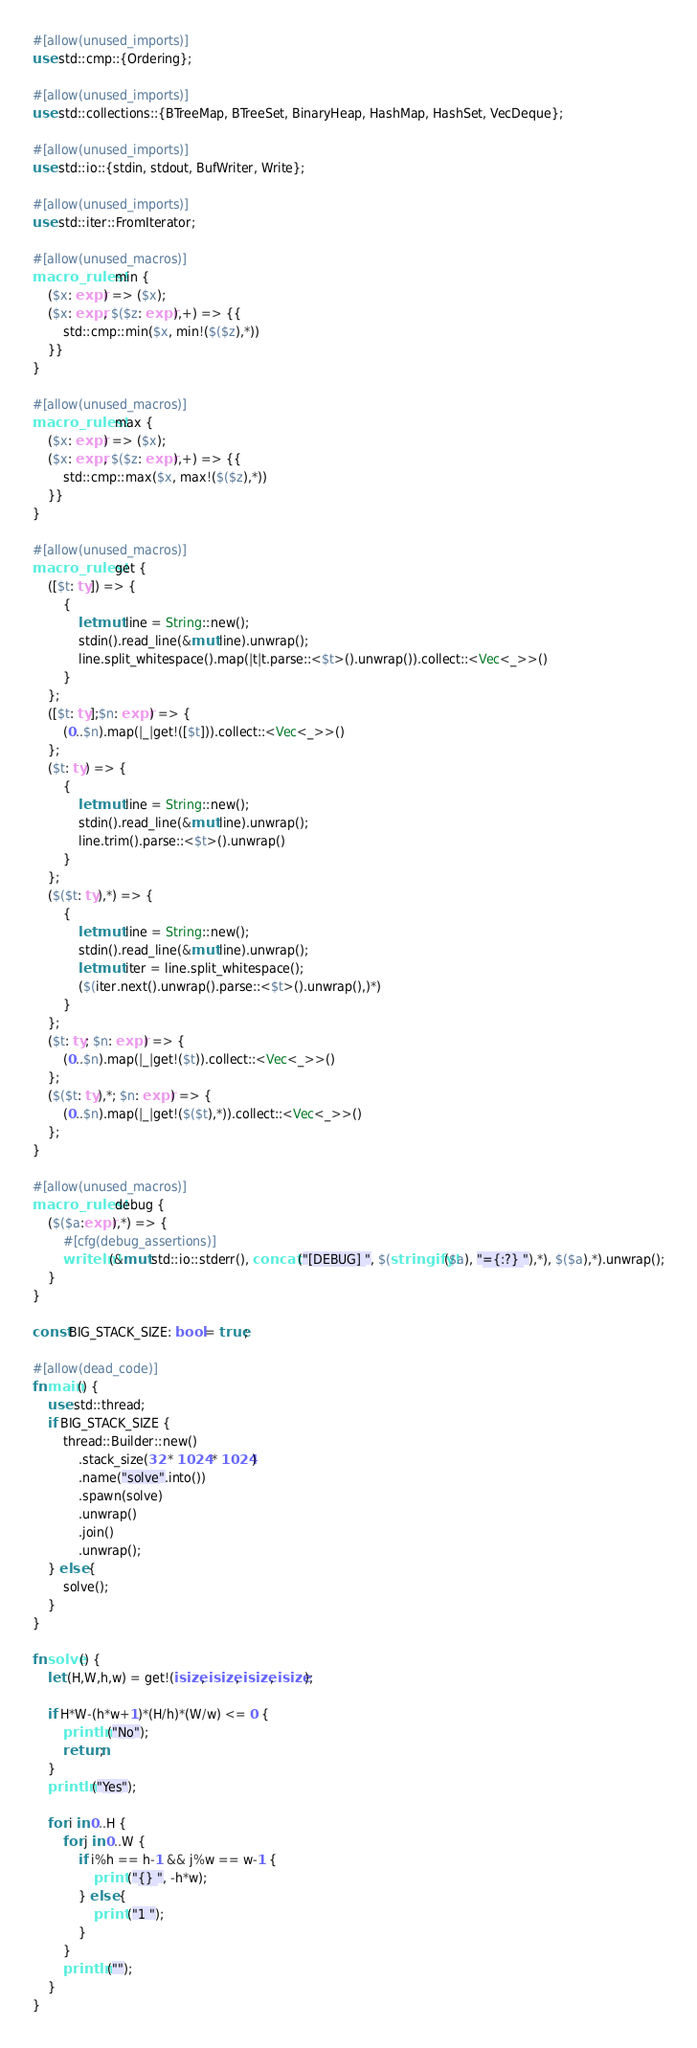<code> <loc_0><loc_0><loc_500><loc_500><_Rust_>#[allow(unused_imports)]
use std::cmp::{Ordering};

#[allow(unused_imports)]
use std::collections::{BTreeMap, BTreeSet, BinaryHeap, HashMap, HashSet, VecDeque};

#[allow(unused_imports)]
use std::io::{stdin, stdout, BufWriter, Write};

#[allow(unused_imports)]
use std::iter::FromIterator;

#[allow(unused_macros)]
macro_rules! min {
    ($x: expr) => ($x);
    ($x: expr, $($z: expr),+) => {{
        std::cmp::min($x, min!($($z),*))
    }}
}

#[allow(unused_macros)]
macro_rules! max {
    ($x: expr) => ($x);
    ($x: expr, $($z: expr),+) => {{
        std::cmp::max($x, max!($($z),*))
    }}
}

#[allow(unused_macros)]
macro_rules! get { 
    ([$t: ty]) => { 
        { 
            let mut line = String::new(); 
            stdin().read_line(&mut line).unwrap(); 
            line.split_whitespace().map(|t|t.parse::<$t>().unwrap()).collect::<Vec<_>>()
        }
    };
    ([$t: ty];$n: expr) => {
        (0..$n).map(|_|get!([$t])).collect::<Vec<_>>()
    };
    ($t: ty) => {
        {
            let mut line = String::new();
            stdin().read_line(&mut line).unwrap();
            line.trim().parse::<$t>().unwrap()
        }
    };
    ($($t: ty),*) => {
        { 
            let mut line = String::new();
            stdin().read_line(&mut line).unwrap();
            let mut iter = line.split_whitespace();
            ($(iter.next().unwrap().parse::<$t>().unwrap(),)*)
        }
    };
    ($t: ty; $n: expr) => {
        (0..$n).map(|_|get!($t)).collect::<Vec<_>>()
    };
    ($($t: ty),*; $n: expr) => {
        (0..$n).map(|_|get!($($t),*)).collect::<Vec<_>>()
    };
}

#[allow(unused_macros)]
macro_rules! debug {
    ($($a:expr),*) => {
        #[cfg(debug_assertions)]
        writeln!(&mut std::io::stderr(), concat!("[DEBUG] ", $(stringify!($a), "={:?} "),*), $($a),*).unwrap();
    }
}

const BIG_STACK_SIZE: bool = true;

#[allow(dead_code)]
fn main() {
    use std::thread;
    if BIG_STACK_SIZE {
        thread::Builder::new()
            .stack_size(32 * 1024 * 1024)
            .name("solve".into())
            .spawn(solve)
            .unwrap()
            .join()
            .unwrap();
    } else {
        solve();
    }
}

fn solve() {
    let (H,W,h,w) = get!(isize, isize, isize, isize);

    if H*W-(h*w+1)*(H/h)*(W/w) <= 0 {
        println!("No");
        return;
    }
    println!("Yes");

    for i in 0..H {
        for j in 0..W {
            if i%h == h-1 && j%w == w-1 {
                print!("{} ", -h*w);
            } else {
                print!("1 ");
            }
        }
        println!("");
    }
}
</code> 